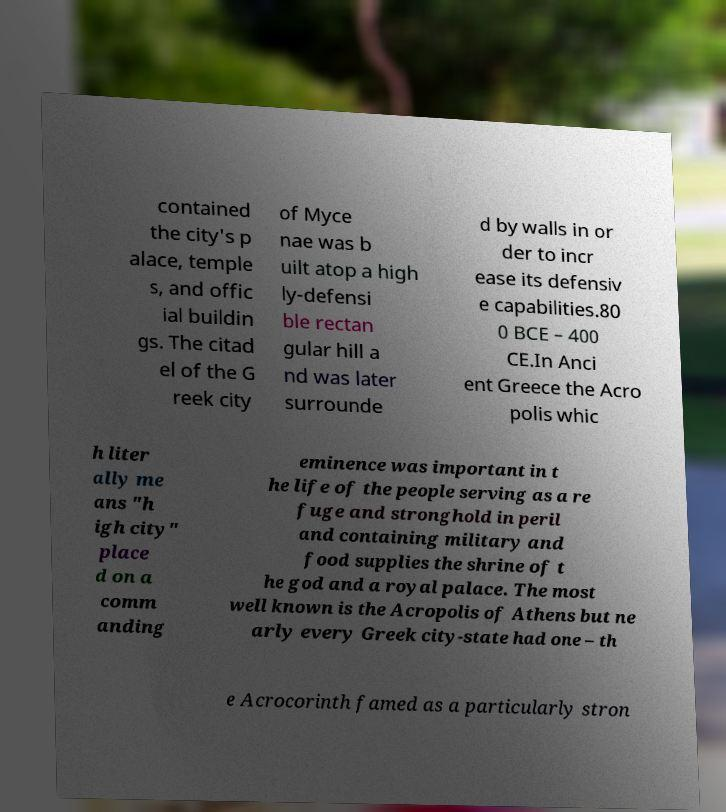I need the written content from this picture converted into text. Can you do that? contained the city's p alace, temple s, and offic ial buildin gs. The citad el of the G reek city of Myce nae was b uilt atop a high ly-defensi ble rectan gular hill a nd was later surrounde d by walls in or der to incr ease its defensiv e capabilities.80 0 BCE – 400 CE.In Anci ent Greece the Acro polis whic h liter ally me ans "h igh city" place d on a comm anding eminence was important in t he life of the people serving as a re fuge and stronghold in peril and containing military and food supplies the shrine of t he god and a royal palace. The most well known is the Acropolis of Athens but ne arly every Greek city-state had one – th e Acrocorinth famed as a particularly stron 